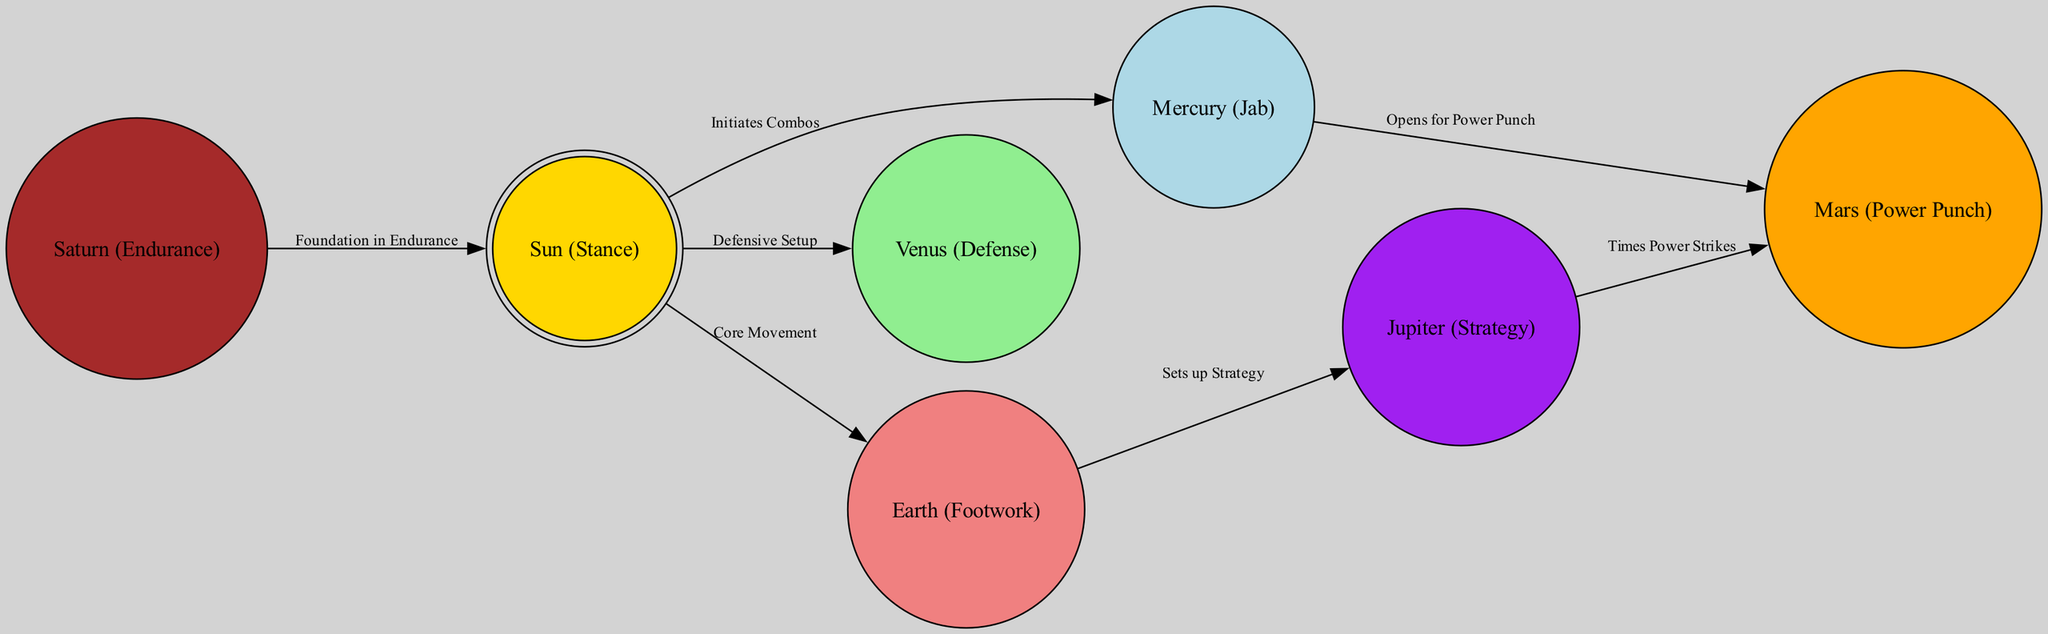What is the central node in the diagram? The diagram identifies the Sun as the central node, representing the foundational position in both celestial alignments and boxing strategies.
Answer: Sun (Stance) How many nodes are represented in the diagram? By counting each unique entity listed as a node in the provided data, there are a total of 7.
Answer: 7 What relationship does Mercury (Jab) have with Mars (Power Punch)? The diagram indicates that Mercury leads to Mars, showing an opening created by a jab that allows for a powerful punch to follow.
Answer: Opens for Power Punch What does Saturn (Endurance) support in the context of the diagram? The relationship depicted in the diagram shows that Saturn supports the Sun, emphasizing the importance of endurance in maintaining a solid foundational stance.
Answer: Foundation in Endurance Which node is associated with strategic planning? The node labeled Jupiter is specifically associated with strategy, indicating its role in long-term planning and exploiting weaknesses in an opponent.
Answer: Jupiter (Strategy) How does Earth (Footwork) contribute to strategy? The link between Earth and Jupiter in the diagram illustrates how effective footwork can set up strategic positioning for the boxer.
Answer: Sets up Strategy What color represents Venus (Defense) in the diagram? Venus is represented with the color light green in the diagram, which is visually distinct and symbolizes balance and guard.
Answer: Light green Which two nodes are directly connected by the label "Times Power Strikes"? The edges labeled "Times Power Strikes" connect Jupiter and Mars, demonstrating the timing involved in executing powerful punches following strategic setup.
Answer: Jupiter, Mars What does the label "Initiates Combos" indicate in the diagram? This label connects the Sun and Mercury, illustrating how the foundational stance allows for a quick jab to initiate combination attacks effectively.
Answer: Initiates Combos 